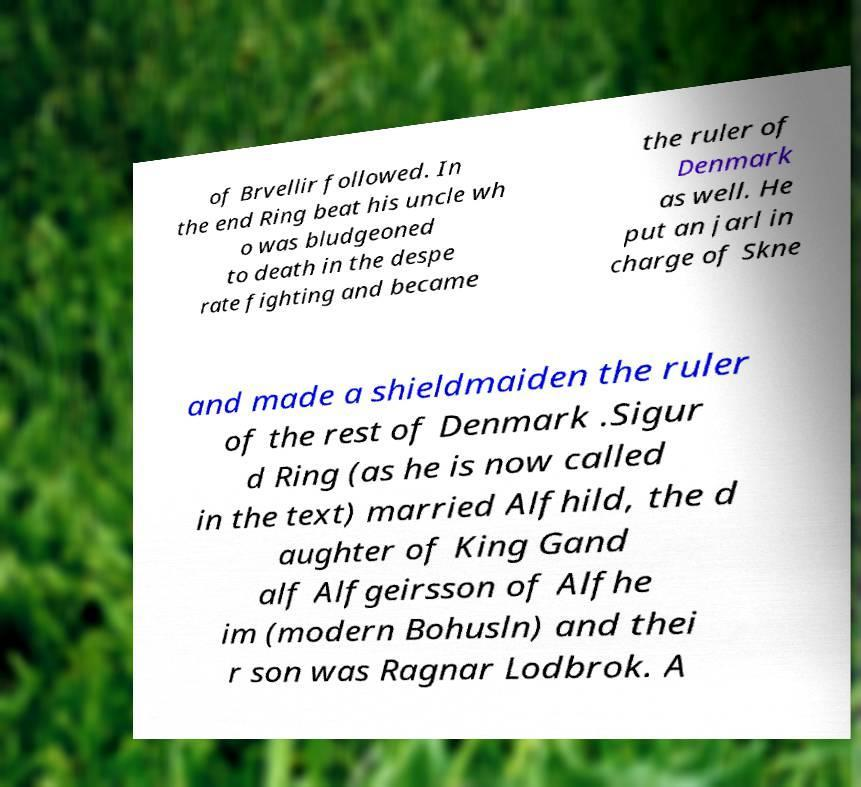Can you read and provide the text displayed in the image?This photo seems to have some interesting text. Can you extract and type it out for me? of Brvellir followed. In the end Ring beat his uncle wh o was bludgeoned to death in the despe rate fighting and became the ruler of Denmark as well. He put an jarl in charge of Skne and made a shieldmaiden the ruler of the rest of Denmark .Sigur d Ring (as he is now called in the text) married Alfhild, the d aughter of King Gand alf Alfgeirsson of Alfhe im (modern Bohusln) and thei r son was Ragnar Lodbrok. A 